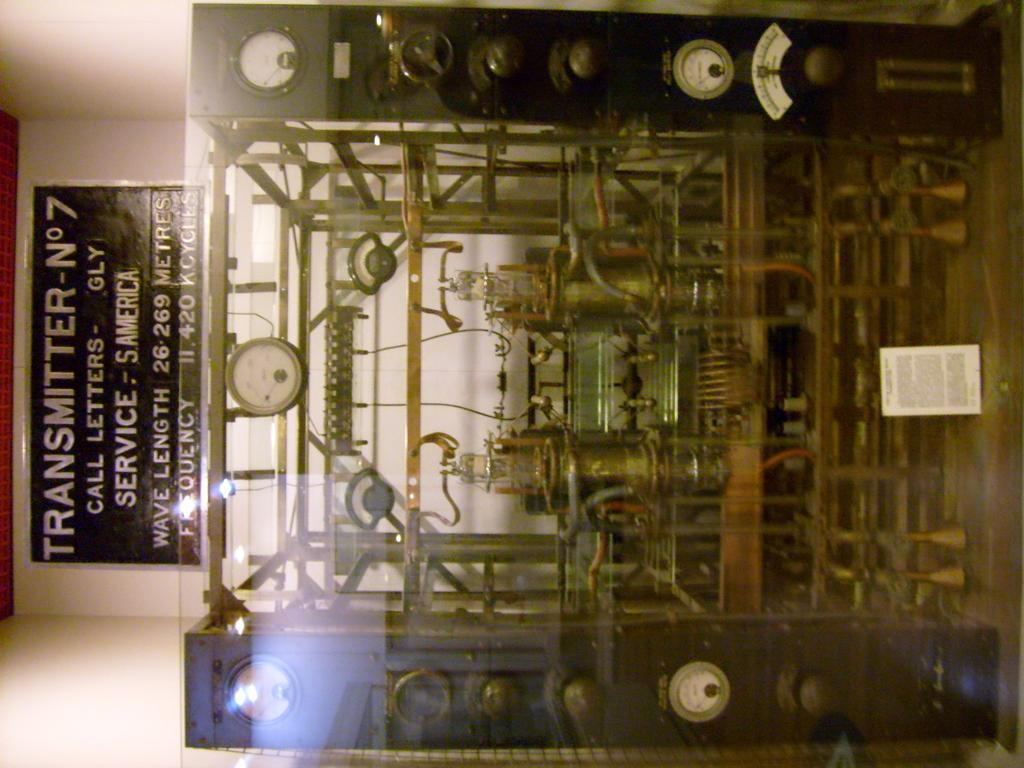What type of object is the main subject in the image? There is a mechanical instrument in the image. What other objects are present in the image related to the mechanical instrument? There are measuring meters in the image. Are there any text-based elements in the image? Yes, there are boards with text in the image. What type of background can be seen in the image? There is a wall in the image. How many legs does the mechanical instrument have in the image? The mechanical instrument in the image does not have legs; it is stationary and attached to the wall. 